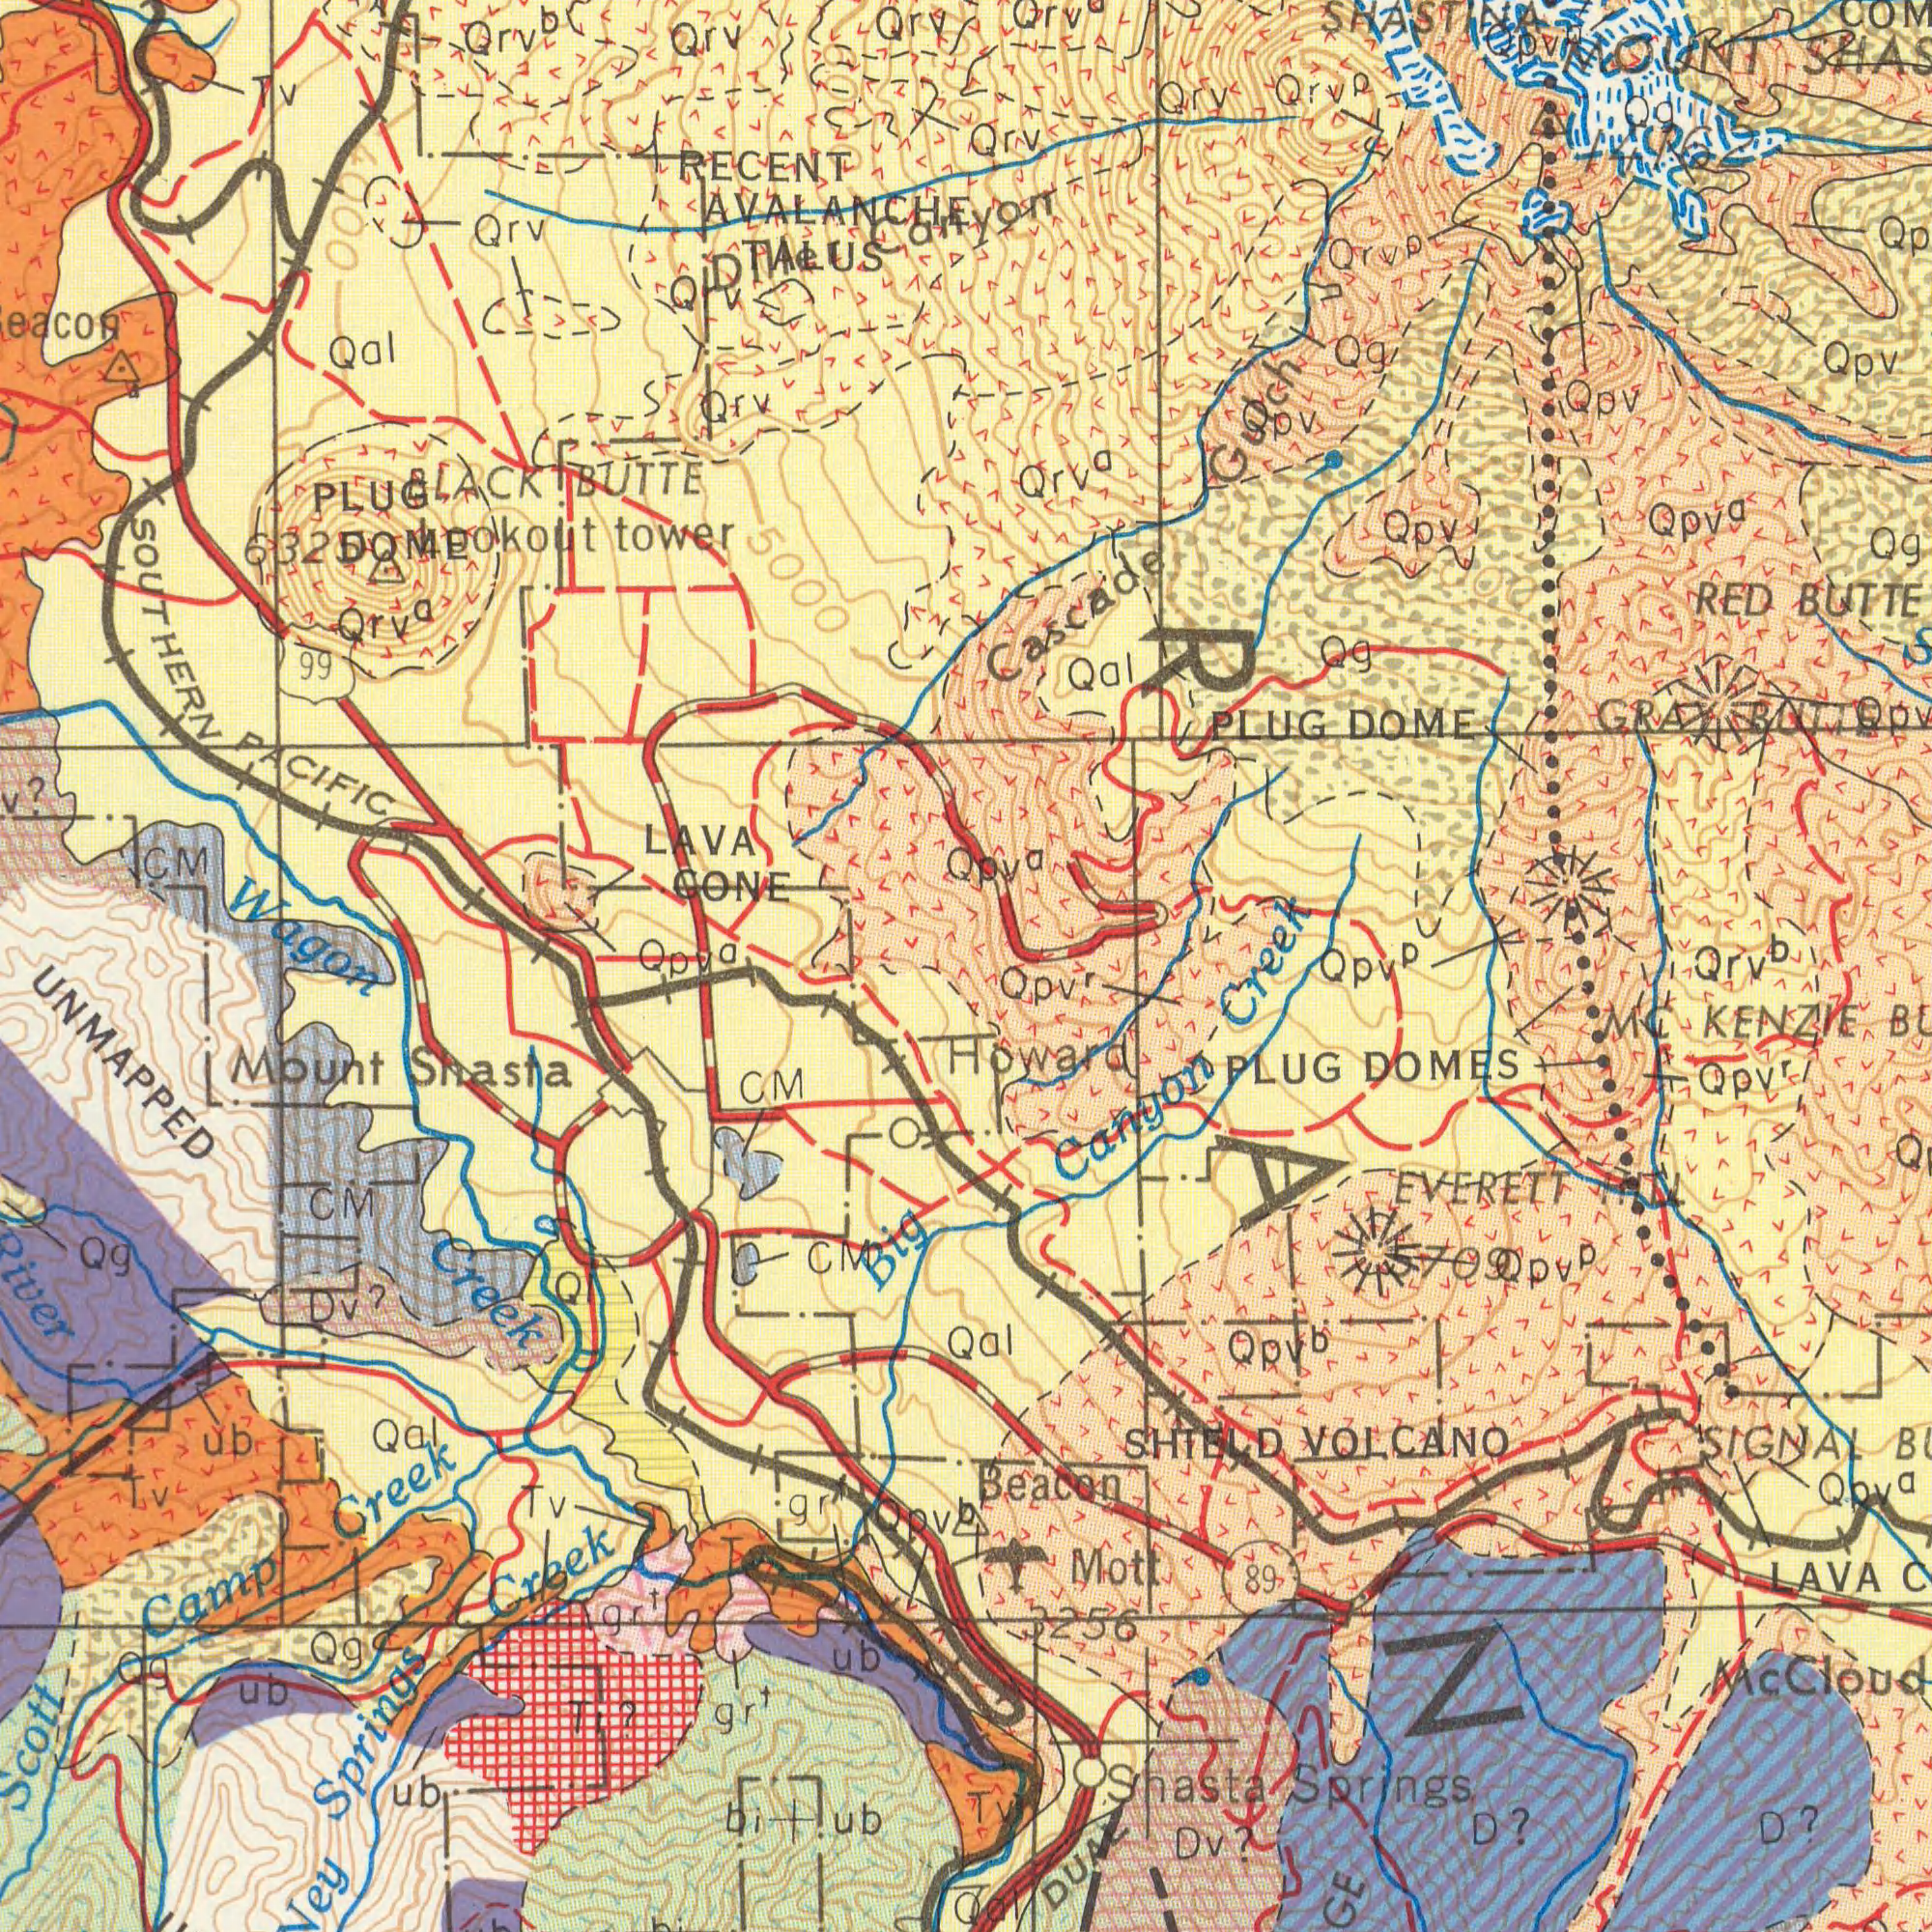What text appears in the bottom-left area of the image? Creek Springs Creek UNMAPPED Mount Shasta CM CM Scott Camp Creek Tv Qal ub. Big Qg bi+ub gr<sup>t</sup> River Ti? Dv? ub ub CM gr<sup>t</sup> Qg Ub Qg Qpv<sup>b</sup> gr<sup>t</sup> Ql What text is shown in the bottom-right quadrant? Canyon Beacon DUAL PLUG DOMES Shasta Springs EVERETT HN LAVA Mott MC KENZIE SHIELD VOLCANO SIGNAL D? Dv? Qpv<sup>r</sup> 89 Qpv<sup>r</sup> D? Howard Qpv<sup>b</sup> 3256 Tv Qpv<sup>a</sup> Mc 5709 Qpv<sup>p</sup> Qal Qal What text is visible in the upper-left corner? LAVA CONE RECENT TALUS Lookout tower Wagon Qrv 5000 AVALANCHE Qal SOUTHERN PACIFIC CM Qrv 99 Qrv Qrv<sup>a</sup> V? BLACK BUTTE Can Tv Qrv Qrv 632 PLUG DOME Qpv<sup>a</sup> Qrv<sup>b</sup> 4000 6000 7000 What text is shown in the top-right quadrant? RED BUTTE Qrv Opv PLUG DOME Orv MOUNT Qpv Qal GRAY BUTTE Qpv<sup>a</sup> Qg yon SHASTINA Cascade Gulch Creek Qrv Qrv<sup>p</sup> Qpv<sup>p</sup> Qg Qpv Qpv Qg Qpv Qrv<sup>p</sup> Qg 14162 Qpv<sup>a</sup> Qrv<sup>b</sup> Qrv<sup>a</sup> Qpv 10000 8000 ###000 